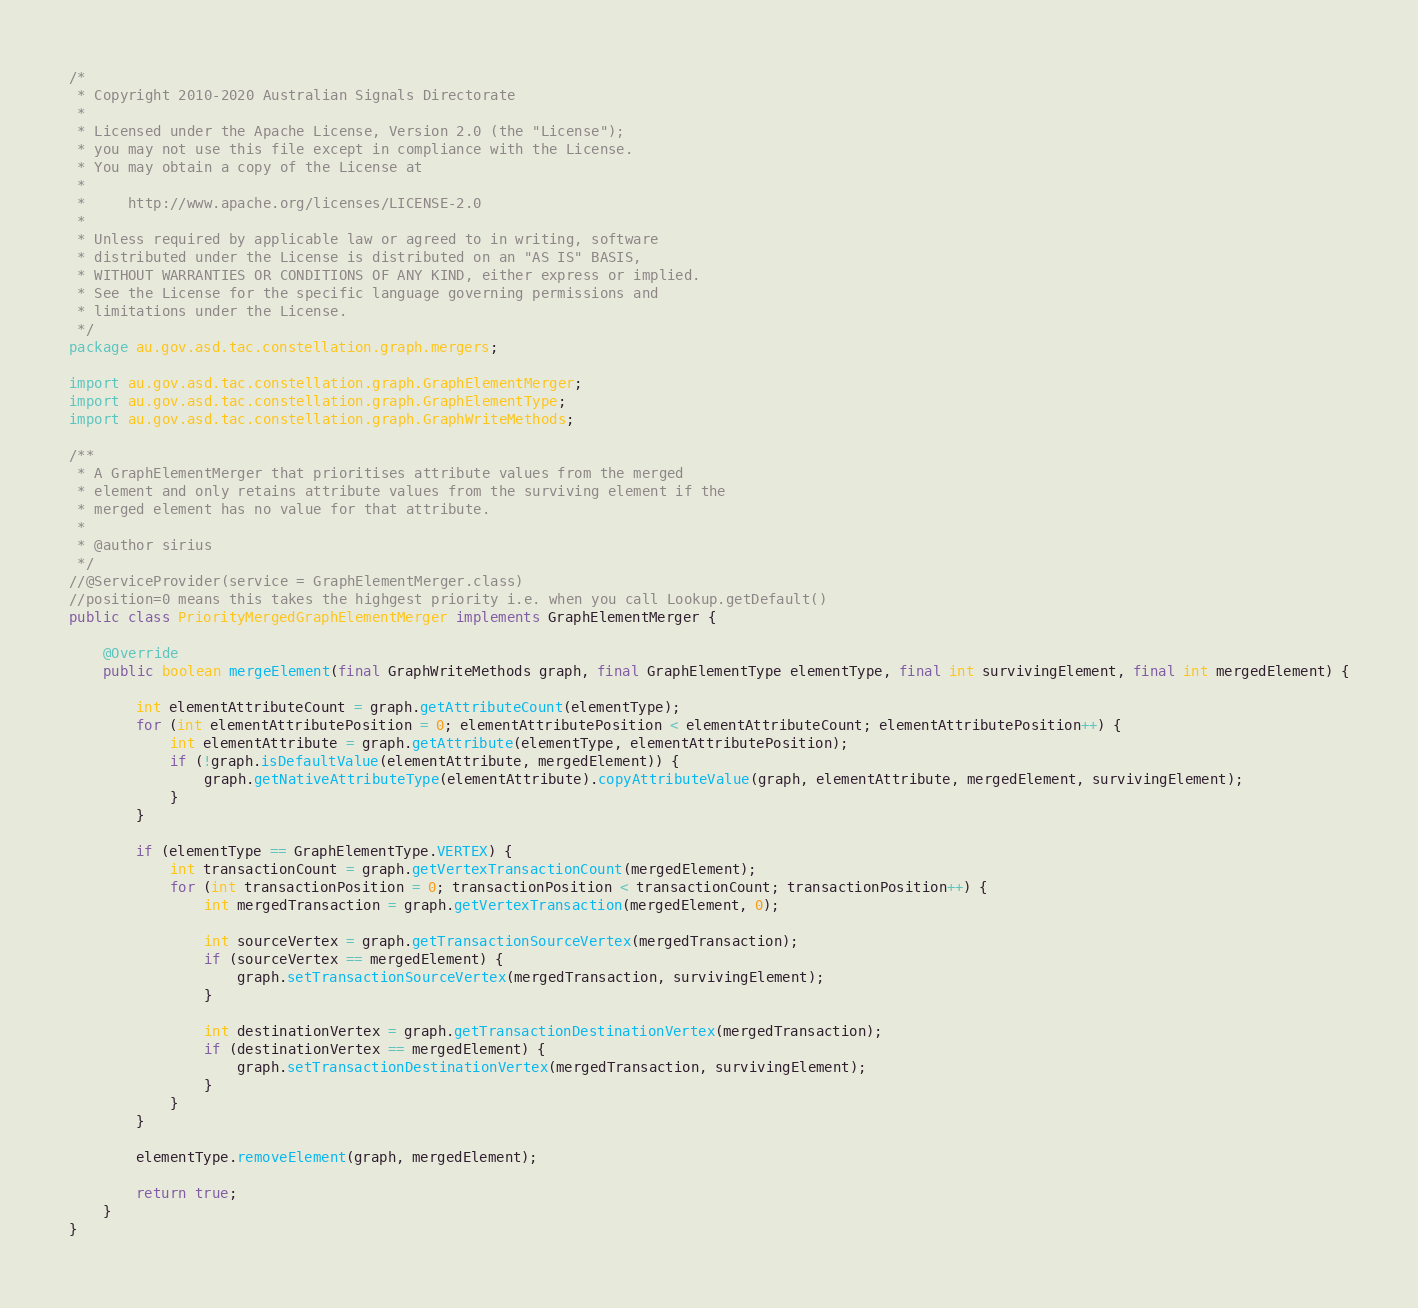<code> <loc_0><loc_0><loc_500><loc_500><_Java_>/*
 * Copyright 2010-2020 Australian Signals Directorate
 *
 * Licensed under the Apache License, Version 2.0 (the "License");
 * you may not use this file except in compliance with the License.
 * You may obtain a copy of the License at
 *
 *     http://www.apache.org/licenses/LICENSE-2.0
 *
 * Unless required by applicable law or agreed to in writing, software
 * distributed under the License is distributed on an "AS IS" BASIS,
 * WITHOUT WARRANTIES OR CONDITIONS OF ANY KIND, either express or implied.
 * See the License for the specific language governing permissions and
 * limitations under the License.
 */
package au.gov.asd.tac.constellation.graph.mergers;

import au.gov.asd.tac.constellation.graph.GraphElementMerger;
import au.gov.asd.tac.constellation.graph.GraphElementType;
import au.gov.asd.tac.constellation.graph.GraphWriteMethods;

/**
 * A GraphElementMerger that prioritises attribute values from the merged
 * element and only retains attribute values from the surviving element if the
 * merged element has no value for that attribute.
 *
 * @author sirius
 */
//@ServiceProvider(service = GraphElementMerger.class)
//position=0 means this takes the highgest priority i.e. when you call Lookup.getDefault()
public class PriorityMergedGraphElementMerger implements GraphElementMerger {

    @Override
    public boolean mergeElement(final GraphWriteMethods graph, final GraphElementType elementType, final int survivingElement, final int mergedElement) {

        int elementAttributeCount = graph.getAttributeCount(elementType);
        for (int elementAttributePosition = 0; elementAttributePosition < elementAttributeCount; elementAttributePosition++) {
            int elementAttribute = graph.getAttribute(elementType, elementAttributePosition);
            if (!graph.isDefaultValue(elementAttribute, mergedElement)) {
                graph.getNativeAttributeType(elementAttribute).copyAttributeValue(graph, elementAttribute, mergedElement, survivingElement);
            }
        }

        if (elementType == GraphElementType.VERTEX) {
            int transactionCount = graph.getVertexTransactionCount(mergedElement);
            for (int transactionPosition = 0; transactionPosition < transactionCount; transactionPosition++) {
                int mergedTransaction = graph.getVertexTransaction(mergedElement, 0);

                int sourceVertex = graph.getTransactionSourceVertex(mergedTransaction);
                if (sourceVertex == mergedElement) {
                    graph.setTransactionSourceVertex(mergedTransaction, survivingElement);
                }

                int destinationVertex = graph.getTransactionDestinationVertex(mergedTransaction);
                if (destinationVertex == mergedElement) {
                    graph.setTransactionDestinationVertex(mergedTransaction, survivingElement);
                }
            }
        }

        elementType.removeElement(graph, mergedElement);

        return true;
    }
}
</code> 